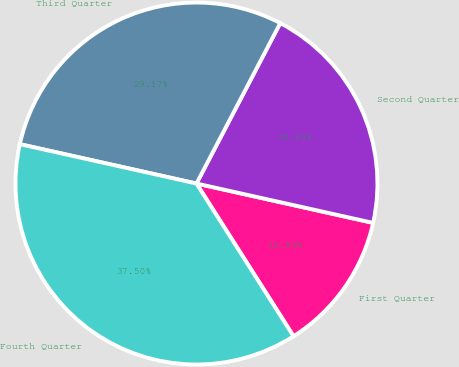Convert chart. <chart><loc_0><loc_0><loc_500><loc_500><pie_chart><fcel>First Quarter<fcel>Second Quarter<fcel>Third Quarter<fcel>Fourth Quarter<nl><fcel>12.5%<fcel>20.83%<fcel>29.17%<fcel>37.5%<nl></chart> 